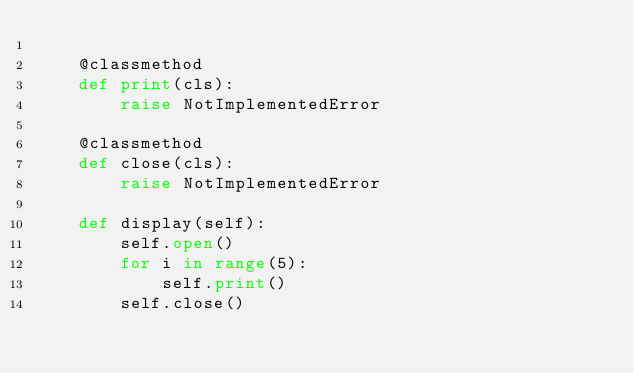<code> <loc_0><loc_0><loc_500><loc_500><_Python_>
    @classmethod
    def print(cls):
        raise NotImplementedError

    @classmethod
    def close(cls):
        raise NotImplementedError

    def display(self):
        self.open()
        for i in range(5):
            self.print()
        self.close()
</code> 